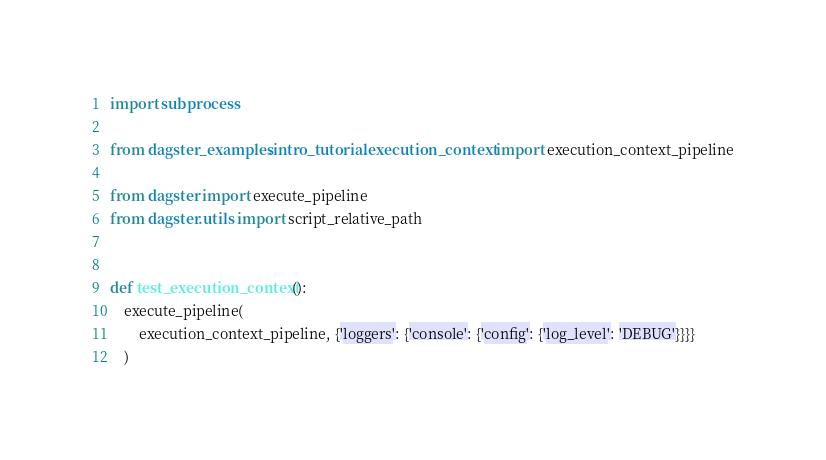<code> <loc_0><loc_0><loc_500><loc_500><_Python_>import subprocess

from dagster_examples.intro_tutorial.execution_context import execution_context_pipeline

from dagster import execute_pipeline
from dagster.utils import script_relative_path


def test_execution_context():
    execute_pipeline(
        execution_context_pipeline, {'loggers': {'console': {'config': {'log_level': 'DEBUG'}}}}
    )

</code> 